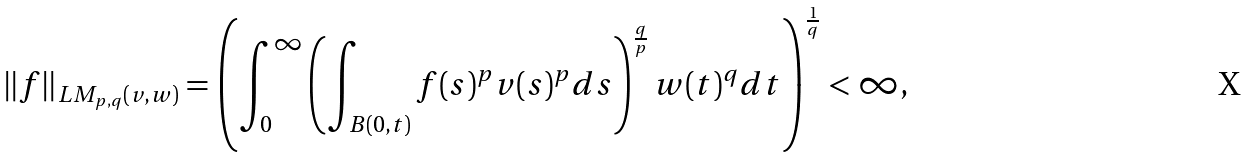Convert formula to latex. <formula><loc_0><loc_0><loc_500><loc_500>\| f \| _ { L M _ { p , q } ( v , w ) } = \left ( \int _ { 0 } ^ { \infty } \left ( \int _ { B ( 0 , t ) } f ( s ) ^ { p } v ( s ) ^ { p } d s \right ) ^ { \frac { q } { p } } w ( t ) ^ { q } d t \right ) ^ { \frac { 1 } { q } } < \infty ,</formula> 